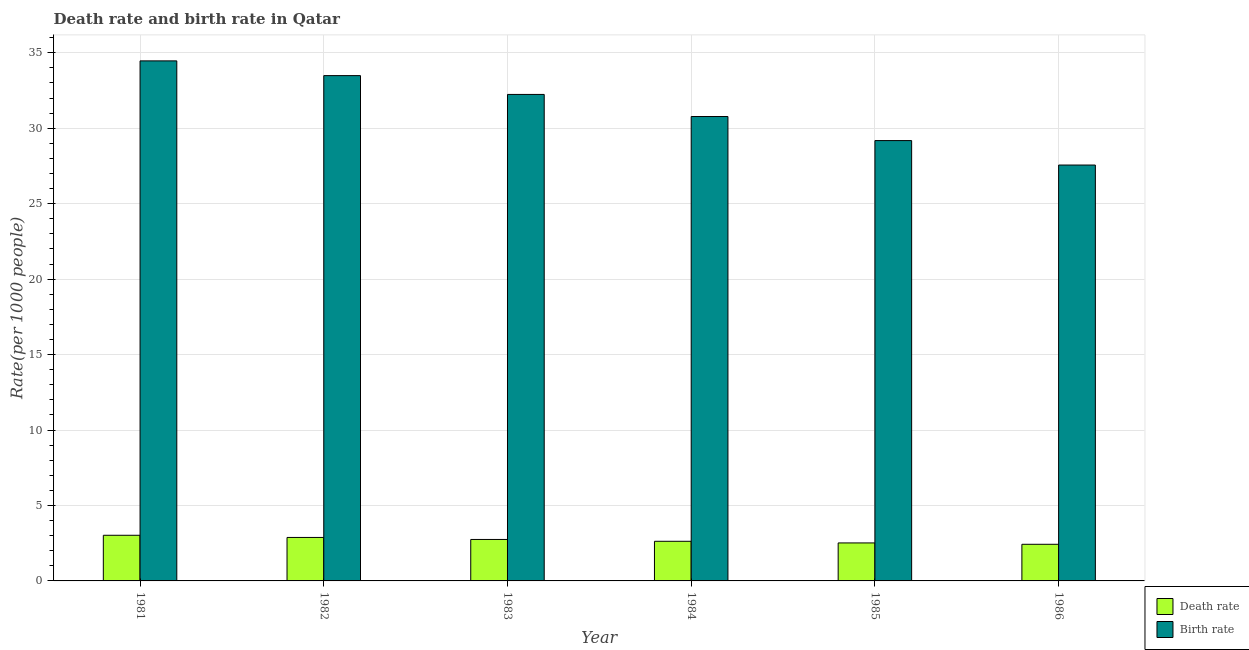How many different coloured bars are there?
Ensure brevity in your answer.  2. How many groups of bars are there?
Offer a terse response. 6. Are the number of bars per tick equal to the number of legend labels?
Offer a very short reply. Yes. Are the number of bars on each tick of the X-axis equal?
Make the answer very short. Yes. How many bars are there on the 2nd tick from the left?
Ensure brevity in your answer.  2. What is the label of the 3rd group of bars from the left?
Your answer should be very brief. 1983. In how many cases, is the number of bars for a given year not equal to the number of legend labels?
Keep it short and to the point. 0. What is the death rate in 1984?
Ensure brevity in your answer.  2.63. Across all years, what is the maximum birth rate?
Provide a short and direct response. 34.46. Across all years, what is the minimum birth rate?
Offer a very short reply. 27.56. What is the total death rate in the graph?
Provide a short and direct response. 16.22. What is the difference between the death rate in 1982 and that in 1984?
Offer a very short reply. 0.25. What is the difference between the birth rate in 1986 and the death rate in 1983?
Provide a succinct answer. -4.68. What is the average death rate per year?
Offer a terse response. 2.7. What is the ratio of the birth rate in 1983 to that in 1984?
Keep it short and to the point. 1.05. Is the birth rate in 1983 less than that in 1986?
Give a very brief answer. No. What is the difference between the highest and the second highest birth rate?
Provide a short and direct response. 0.98. What is the difference between the highest and the lowest birth rate?
Give a very brief answer. 6.9. In how many years, is the death rate greater than the average death rate taken over all years?
Give a very brief answer. 3. Is the sum of the death rate in 1981 and 1983 greater than the maximum birth rate across all years?
Give a very brief answer. Yes. What does the 1st bar from the left in 1985 represents?
Your answer should be compact. Death rate. What does the 1st bar from the right in 1984 represents?
Your answer should be compact. Birth rate. What is the difference between two consecutive major ticks on the Y-axis?
Your answer should be compact. 5. Does the graph contain any zero values?
Your response must be concise. No. Does the graph contain grids?
Offer a very short reply. Yes. Where does the legend appear in the graph?
Your answer should be very brief. Bottom right. How are the legend labels stacked?
Your answer should be compact. Vertical. What is the title of the graph?
Make the answer very short. Death rate and birth rate in Qatar. What is the label or title of the Y-axis?
Make the answer very short. Rate(per 1000 people). What is the Rate(per 1000 people) of Death rate in 1981?
Your answer should be very brief. 3.02. What is the Rate(per 1000 people) in Birth rate in 1981?
Keep it short and to the point. 34.46. What is the Rate(per 1000 people) of Death rate in 1982?
Offer a terse response. 2.88. What is the Rate(per 1000 people) of Birth rate in 1982?
Ensure brevity in your answer.  33.48. What is the Rate(per 1000 people) in Death rate in 1983?
Ensure brevity in your answer.  2.75. What is the Rate(per 1000 people) in Birth rate in 1983?
Offer a very short reply. 32.24. What is the Rate(per 1000 people) of Death rate in 1984?
Provide a short and direct response. 2.63. What is the Rate(per 1000 people) in Birth rate in 1984?
Give a very brief answer. 30.77. What is the Rate(per 1000 people) in Death rate in 1985?
Offer a very short reply. 2.52. What is the Rate(per 1000 people) in Birth rate in 1985?
Your answer should be very brief. 29.18. What is the Rate(per 1000 people) in Death rate in 1986?
Your answer should be very brief. 2.43. What is the Rate(per 1000 people) of Birth rate in 1986?
Offer a terse response. 27.56. Across all years, what is the maximum Rate(per 1000 people) in Death rate?
Provide a short and direct response. 3.02. Across all years, what is the maximum Rate(per 1000 people) of Birth rate?
Your answer should be very brief. 34.46. Across all years, what is the minimum Rate(per 1000 people) of Death rate?
Provide a short and direct response. 2.43. Across all years, what is the minimum Rate(per 1000 people) in Birth rate?
Keep it short and to the point. 27.56. What is the total Rate(per 1000 people) in Death rate in the graph?
Make the answer very short. 16.22. What is the total Rate(per 1000 people) in Birth rate in the graph?
Provide a succinct answer. 187.69. What is the difference between the Rate(per 1000 people) in Death rate in 1981 and that in 1982?
Make the answer very short. 0.14. What is the difference between the Rate(per 1000 people) in Death rate in 1981 and that in 1983?
Your answer should be compact. 0.28. What is the difference between the Rate(per 1000 people) of Birth rate in 1981 and that in 1983?
Offer a very short reply. 2.22. What is the difference between the Rate(per 1000 people) of Death rate in 1981 and that in 1984?
Make the answer very short. 0.4. What is the difference between the Rate(per 1000 people) in Birth rate in 1981 and that in 1984?
Offer a terse response. 3.69. What is the difference between the Rate(per 1000 people) in Death rate in 1981 and that in 1985?
Your response must be concise. 0.51. What is the difference between the Rate(per 1000 people) of Birth rate in 1981 and that in 1985?
Make the answer very short. 5.28. What is the difference between the Rate(per 1000 people) of Death rate in 1981 and that in 1986?
Offer a terse response. 0.6. What is the difference between the Rate(per 1000 people) of Birth rate in 1981 and that in 1986?
Offer a very short reply. 6.9. What is the difference between the Rate(per 1000 people) in Death rate in 1982 and that in 1983?
Provide a short and direct response. 0.13. What is the difference between the Rate(per 1000 people) in Birth rate in 1982 and that in 1983?
Your response must be concise. 1.25. What is the difference between the Rate(per 1000 people) of Death rate in 1982 and that in 1984?
Offer a terse response. 0.26. What is the difference between the Rate(per 1000 people) of Birth rate in 1982 and that in 1984?
Give a very brief answer. 2.71. What is the difference between the Rate(per 1000 people) of Death rate in 1982 and that in 1985?
Ensure brevity in your answer.  0.36. What is the difference between the Rate(per 1000 people) in Birth rate in 1982 and that in 1985?
Give a very brief answer. 4.3. What is the difference between the Rate(per 1000 people) in Death rate in 1982 and that in 1986?
Your answer should be compact. 0.45. What is the difference between the Rate(per 1000 people) in Birth rate in 1982 and that in 1986?
Ensure brevity in your answer.  5.92. What is the difference between the Rate(per 1000 people) of Death rate in 1983 and that in 1984?
Your answer should be compact. 0.12. What is the difference between the Rate(per 1000 people) of Birth rate in 1983 and that in 1984?
Keep it short and to the point. 1.46. What is the difference between the Rate(per 1000 people) of Death rate in 1983 and that in 1985?
Provide a short and direct response. 0.23. What is the difference between the Rate(per 1000 people) of Birth rate in 1983 and that in 1985?
Your response must be concise. 3.06. What is the difference between the Rate(per 1000 people) of Death rate in 1983 and that in 1986?
Ensure brevity in your answer.  0.32. What is the difference between the Rate(per 1000 people) of Birth rate in 1983 and that in 1986?
Offer a very short reply. 4.68. What is the difference between the Rate(per 1000 people) of Death rate in 1984 and that in 1985?
Keep it short and to the point. 0.11. What is the difference between the Rate(per 1000 people) of Birth rate in 1984 and that in 1985?
Your answer should be compact. 1.59. What is the difference between the Rate(per 1000 people) of Death rate in 1984 and that in 1986?
Offer a terse response. 0.2. What is the difference between the Rate(per 1000 people) in Birth rate in 1984 and that in 1986?
Provide a succinct answer. 3.21. What is the difference between the Rate(per 1000 people) in Death rate in 1985 and that in 1986?
Make the answer very short. 0.09. What is the difference between the Rate(per 1000 people) in Birth rate in 1985 and that in 1986?
Give a very brief answer. 1.62. What is the difference between the Rate(per 1000 people) of Death rate in 1981 and the Rate(per 1000 people) of Birth rate in 1982?
Provide a succinct answer. -30.46. What is the difference between the Rate(per 1000 people) in Death rate in 1981 and the Rate(per 1000 people) in Birth rate in 1983?
Your answer should be very brief. -29.21. What is the difference between the Rate(per 1000 people) of Death rate in 1981 and the Rate(per 1000 people) of Birth rate in 1984?
Your answer should be very brief. -27.75. What is the difference between the Rate(per 1000 people) in Death rate in 1981 and the Rate(per 1000 people) in Birth rate in 1985?
Make the answer very short. -26.15. What is the difference between the Rate(per 1000 people) in Death rate in 1981 and the Rate(per 1000 people) in Birth rate in 1986?
Keep it short and to the point. -24.53. What is the difference between the Rate(per 1000 people) of Death rate in 1982 and the Rate(per 1000 people) of Birth rate in 1983?
Provide a succinct answer. -29.36. What is the difference between the Rate(per 1000 people) of Death rate in 1982 and the Rate(per 1000 people) of Birth rate in 1984?
Offer a very short reply. -27.89. What is the difference between the Rate(per 1000 people) in Death rate in 1982 and the Rate(per 1000 people) in Birth rate in 1985?
Keep it short and to the point. -26.3. What is the difference between the Rate(per 1000 people) of Death rate in 1982 and the Rate(per 1000 people) of Birth rate in 1986?
Offer a terse response. -24.68. What is the difference between the Rate(per 1000 people) of Death rate in 1983 and the Rate(per 1000 people) of Birth rate in 1984?
Make the answer very short. -28.03. What is the difference between the Rate(per 1000 people) of Death rate in 1983 and the Rate(per 1000 people) of Birth rate in 1985?
Your response must be concise. -26.43. What is the difference between the Rate(per 1000 people) of Death rate in 1983 and the Rate(per 1000 people) of Birth rate in 1986?
Offer a very short reply. -24.81. What is the difference between the Rate(per 1000 people) of Death rate in 1984 and the Rate(per 1000 people) of Birth rate in 1985?
Your answer should be compact. -26.55. What is the difference between the Rate(per 1000 people) of Death rate in 1984 and the Rate(per 1000 people) of Birth rate in 1986?
Make the answer very short. -24.93. What is the difference between the Rate(per 1000 people) of Death rate in 1985 and the Rate(per 1000 people) of Birth rate in 1986?
Provide a short and direct response. -25.04. What is the average Rate(per 1000 people) of Death rate per year?
Offer a very short reply. 2.7. What is the average Rate(per 1000 people) in Birth rate per year?
Give a very brief answer. 31.28. In the year 1981, what is the difference between the Rate(per 1000 people) in Death rate and Rate(per 1000 people) in Birth rate?
Your answer should be very brief. -31.44. In the year 1982, what is the difference between the Rate(per 1000 people) in Death rate and Rate(per 1000 people) in Birth rate?
Ensure brevity in your answer.  -30.6. In the year 1983, what is the difference between the Rate(per 1000 people) of Death rate and Rate(per 1000 people) of Birth rate?
Ensure brevity in your answer.  -29.49. In the year 1984, what is the difference between the Rate(per 1000 people) in Death rate and Rate(per 1000 people) in Birth rate?
Keep it short and to the point. -28.15. In the year 1985, what is the difference between the Rate(per 1000 people) in Death rate and Rate(per 1000 people) in Birth rate?
Provide a succinct answer. -26.66. In the year 1986, what is the difference between the Rate(per 1000 people) in Death rate and Rate(per 1000 people) in Birth rate?
Make the answer very short. -25.13. What is the ratio of the Rate(per 1000 people) of Birth rate in 1981 to that in 1982?
Your answer should be very brief. 1.03. What is the ratio of the Rate(per 1000 people) of Death rate in 1981 to that in 1983?
Your answer should be compact. 1.1. What is the ratio of the Rate(per 1000 people) of Birth rate in 1981 to that in 1983?
Your answer should be compact. 1.07. What is the ratio of the Rate(per 1000 people) of Death rate in 1981 to that in 1984?
Give a very brief answer. 1.15. What is the ratio of the Rate(per 1000 people) of Birth rate in 1981 to that in 1984?
Provide a succinct answer. 1.12. What is the ratio of the Rate(per 1000 people) in Death rate in 1981 to that in 1985?
Provide a short and direct response. 1.2. What is the ratio of the Rate(per 1000 people) of Birth rate in 1981 to that in 1985?
Offer a terse response. 1.18. What is the ratio of the Rate(per 1000 people) in Death rate in 1981 to that in 1986?
Your response must be concise. 1.25. What is the ratio of the Rate(per 1000 people) in Birth rate in 1981 to that in 1986?
Offer a terse response. 1.25. What is the ratio of the Rate(per 1000 people) of Death rate in 1982 to that in 1983?
Offer a very short reply. 1.05. What is the ratio of the Rate(per 1000 people) of Birth rate in 1982 to that in 1983?
Your answer should be very brief. 1.04. What is the ratio of the Rate(per 1000 people) in Death rate in 1982 to that in 1984?
Your answer should be compact. 1.1. What is the ratio of the Rate(per 1000 people) of Birth rate in 1982 to that in 1984?
Give a very brief answer. 1.09. What is the ratio of the Rate(per 1000 people) in Death rate in 1982 to that in 1985?
Keep it short and to the point. 1.14. What is the ratio of the Rate(per 1000 people) in Birth rate in 1982 to that in 1985?
Your answer should be very brief. 1.15. What is the ratio of the Rate(per 1000 people) in Death rate in 1982 to that in 1986?
Your answer should be compact. 1.19. What is the ratio of the Rate(per 1000 people) in Birth rate in 1982 to that in 1986?
Your response must be concise. 1.22. What is the ratio of the Rate(per 1000 people) of Death rate in 1983 to that in 1984?
Keep it short and to the point. 1.05. What is the ratio of the Rate(per 1000 people) of Birth rate in 1983 to that in 1984?
Make the answer very short. 1.05. What is the ratio of the Rate(per 1000 people) of Birth rate in 1983 to that in 1985?
Provide a short and direct response. 1.1. What is the ratio of the Rate(per 1000 people) of Death rate in 1983 to that in 1986?
Your answer should be compact. 1.13. What is the ratio of the Rate(per 1000 people) of Birth rate in 1983 to that in 1986?
Offer a terse response. 1.17. What is the ratio of the Rate(per 1000 people) of Death rate in 1984 to that in 1985?
Your answer should be very brief. 1.04. What is the ratio of the Rate(per 1000 people) in Birth rate in 1984 to that in 1985?
Give a very brief answer. 1.05. What is the ratio of the Rate(per 1000 people) in Death rate in 1984 to that in 1986?
Your answer should be very brief. 1.08. What is the ratio of the Rate(per 1000 people) of Birth rate in 1984 to that in 1986?
Offer a terse response. 1.12. What is the ratio of the Rate(per 1000 people) of Death rate in 1985 to that in 1986?
Your answer should be very brief. 1.04. What is the ratio of the Rate(per 1000 people) in Birth rate in 1985 to that in 1986?
Provide a short and direct response. 1.06. What is the difference between the highest and the second highest Rate(per 1000 people) of Death rate?
Ensure brevity in your answer.  0.14. What is the difference between the highest and the lowest Rate(per 1000 people) of Death rate?
Offer a terse response. 0.6. What is the difference between the highest and the lowest Rate(per 1000 people) in Birth rate?
Provide a short and direct response. 6.9. 